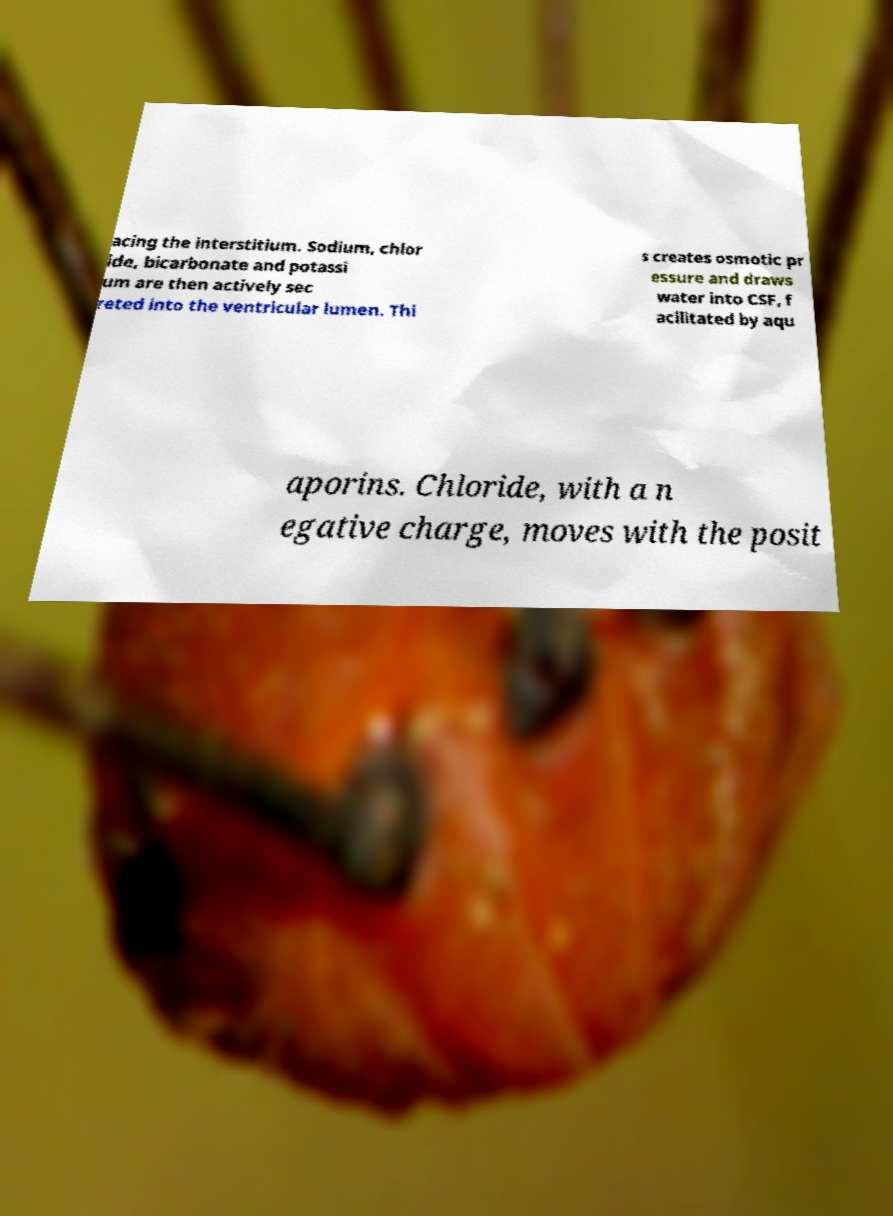For documentation purposes, I need the text within this image transcribed. Could you provide that? acing the interstitium. Sodium, chlor ide, bicarbonate and potassi um are then actively sec reted into the ventricular lumen. Thi s creates osmotic pr essure and draws water into CSF, f acilitated by aqu aporins. Chloride, with a n egative charge, moves with the posit 